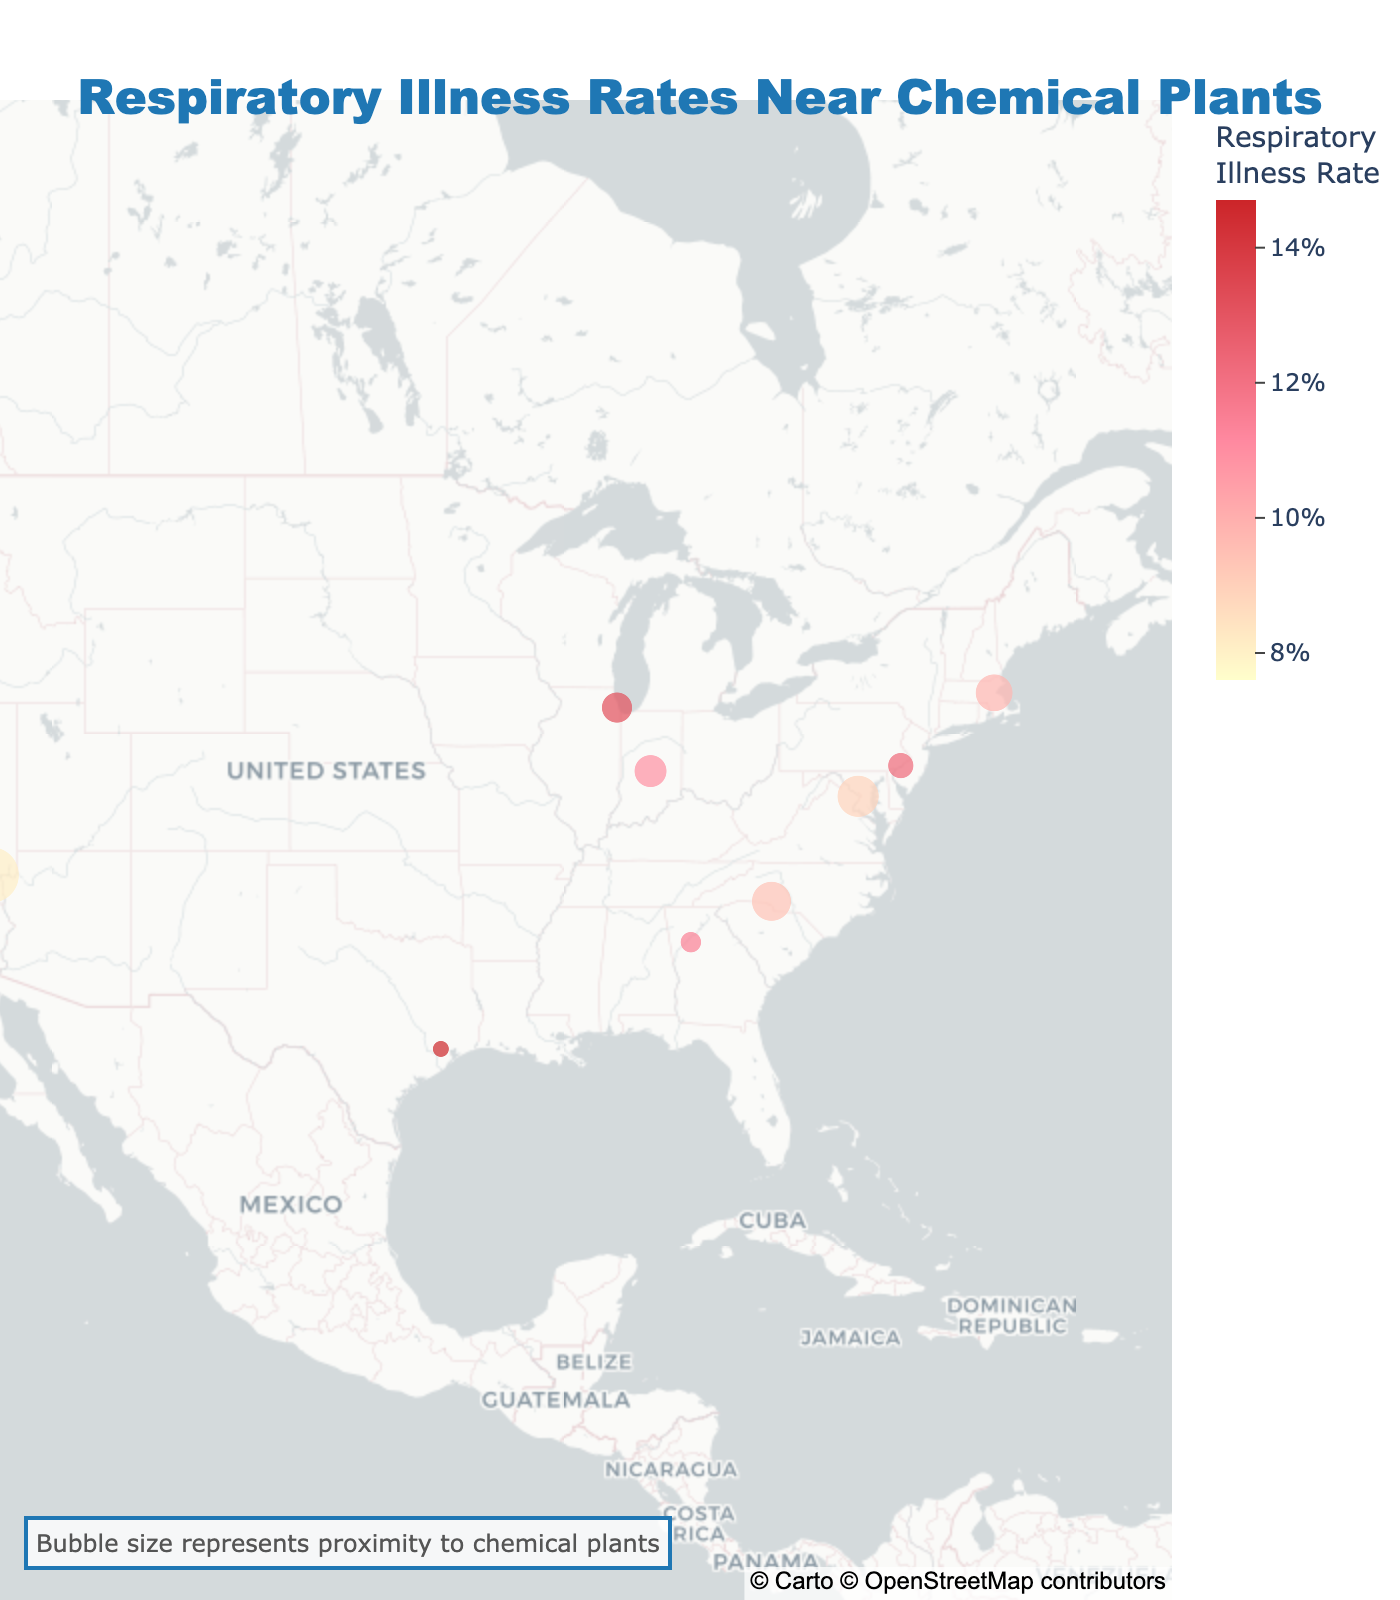What is the title of the figure? The title is prominently displayed at the top center of the figure. It reads "Respiratory Illness Rates Near Chemical Plants".
Answer: Respiratory Illness Rates Near Chemical Plants Which city has the highest respiratory illness rate? To find this, look at the color intensity and hover data in the plot. Houston, TX, with the darkest color, has the highest rate of 14.7%.
Answer: Houston, TX How many cities are represented in the figure? Count the number of distinct points on the map. There are 10 cities on the map.
Answer: 10 What does the size of the bubbles represent? According to the custom annotation, the size of the bubbles represents the proximity to chemical plants.
Answer: Proximity to chemical plants Which city has the largest bubble size, indicating the closest proximity to chemical plants? The largest bubble, indicating the closest proximity, is located at Las Vegas, NV, with a proximity of 5.6.
Answer: Las Vegas, NV Which city has the lowest respiratory illness rate? Look for the lightest color bubble. San Diego, CA has the lowest illness rate of 7.6%.
Answer: San Diego, CA What is the respiratory illness rate for Boston, MA? Hover over Boston, MA on the map to reveal the hover data showing a respiratory illness rate of 9.8%.
Answer: 9.8% Compare the respiratory illness rates between Chicago, IL and Philadelphia, PA. Which is higher? Chicago, IL has a rate of 13.2%, and Philadelphia, PA has a rate of 12.3%. Chicago's rate is higher.
Answer: Chicago, IL Which city has the closest proximity to chemical plants but the lowest illness rate? San Diego, CA has a low illness rate of 7.6% despite a high proximity of 4.2.
Answer: San Diego, CA Determine the average respiratory illness rate for all cities shown. Sum all rates (12.3 + 9.8 + 11.5 + 14.7 + 8.9 + 13.2 + 7.6 + 10.9 + 9.4 + 8.1) which equals 106.4. Divide by the number of cities (10): 106.4 / 10 = 10.64%.
Answer: 10.64% 